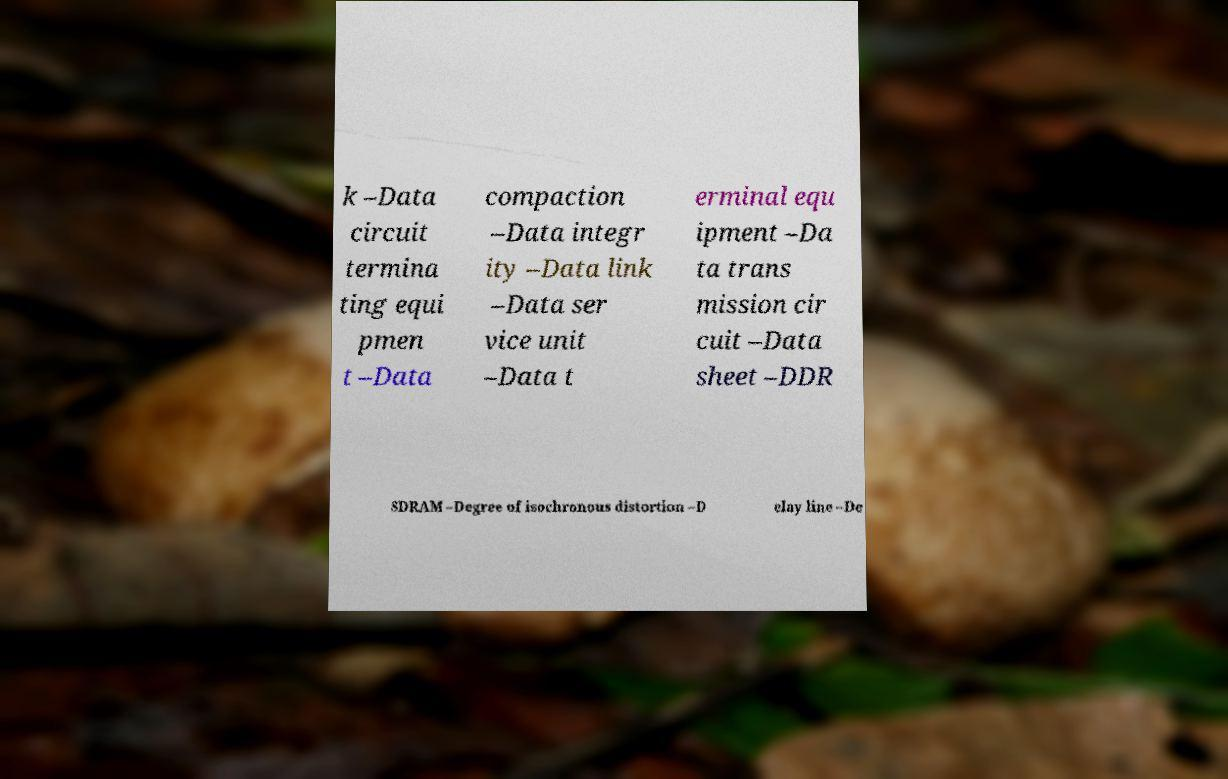What messages or text are displayed in this image? I need them in a readable, typed format. k –Data circuit termina ting equi pmen t –Data compaction –Data integr ity –Data link –Data ser vice unit –Data t erminal equ ipment –Da ta trans mission cir cuit –Data sheet –DDR SDRAM –Degree of isochronous distortion –D elay line –De 